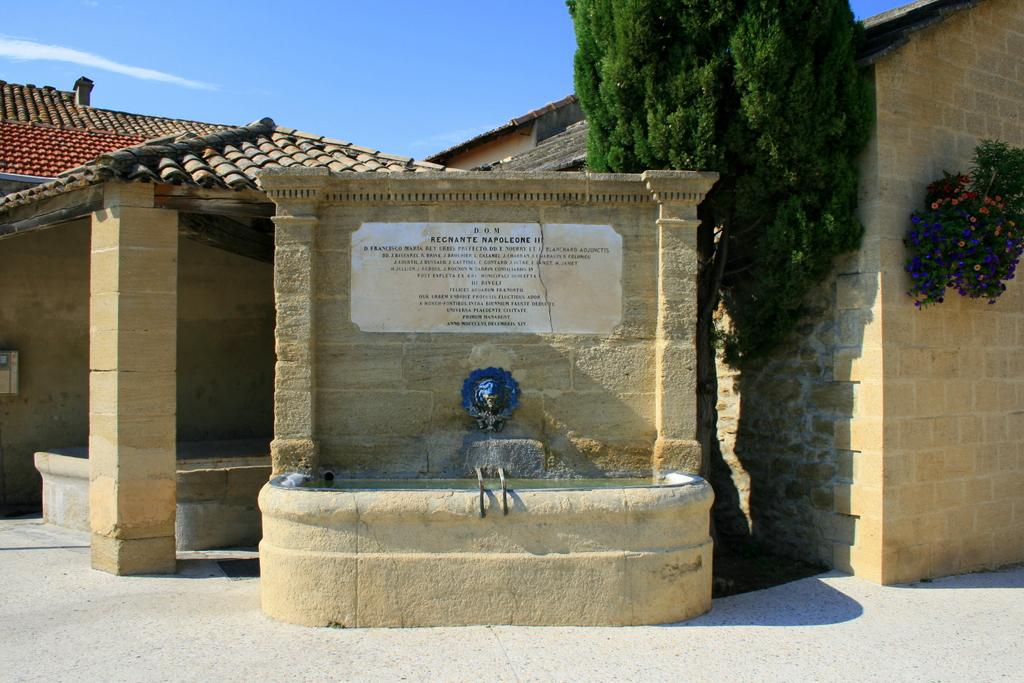What is the main subject in the center of the image? There is a name board and a water fountain in the center of the image. What can be seen in the background of the image? There is a building, trees, and the sky visible in the background of the image. What is the condition of the sky in the image? The sky is visible in the background of the image, and there are clouds present. Can you tell me how many yaks are grazing near the water fountain in the image? There are no yaks present in the image; it features a name board and a water fountain in the center, with a background of a building, trees, and the sky. What advice might the aunt give to someone in the image? There is no aunt present in the image, so it is not possible to determine any advice she might give. 